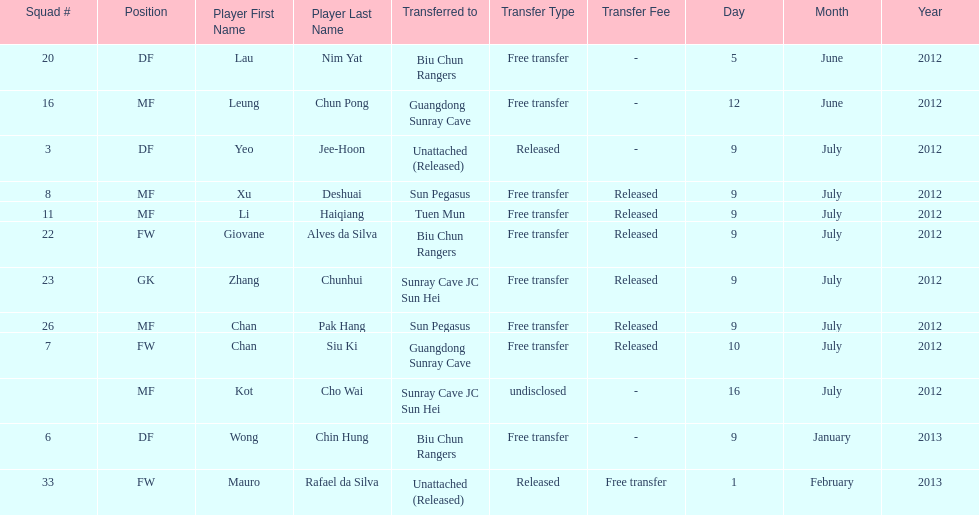Who is the first player listed? Lau Nim Yat. 